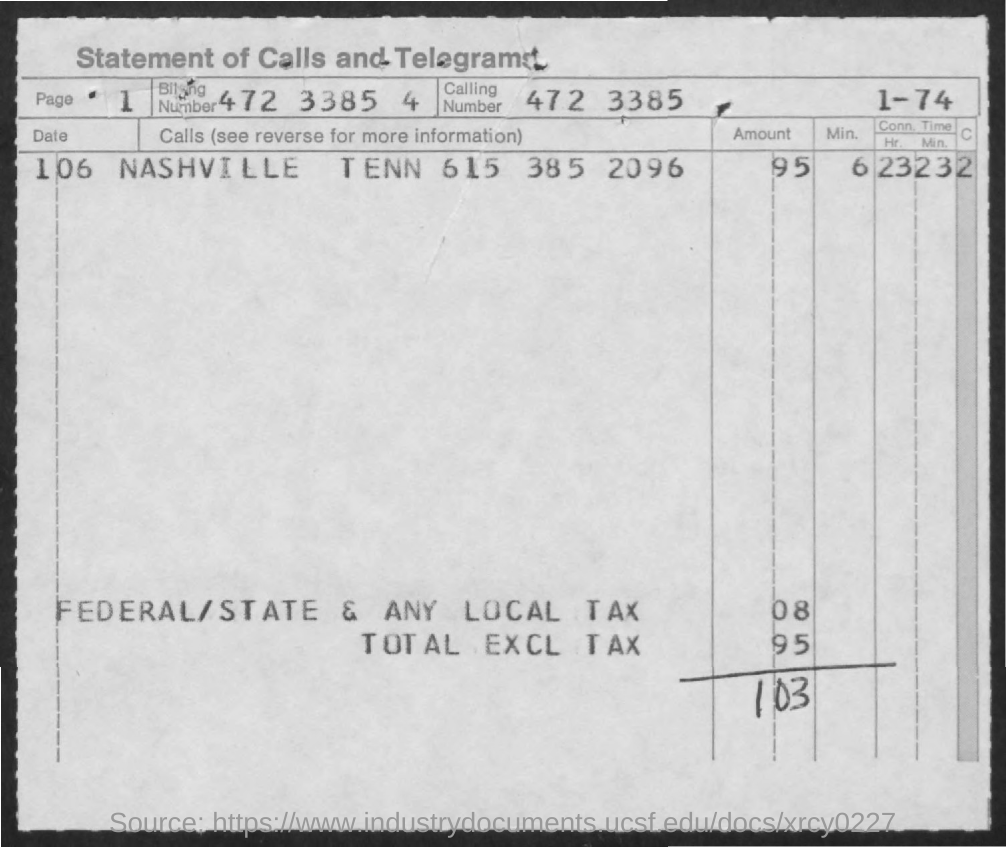Identify some key points in this picture. The total amount, exclusive of tax, is 95. The calling number is 472 3385. 